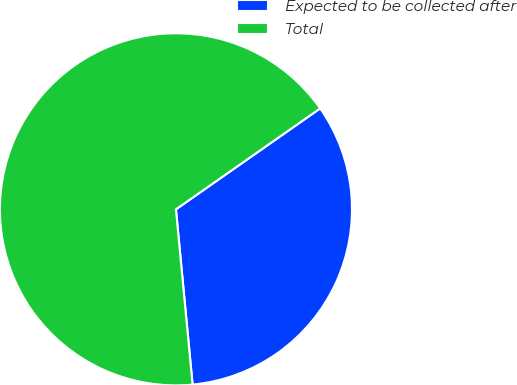Convert chart. <chart><loc_0><loc_0><loc_500><loc_500><pie_chart><fcel>Expected to be collected after<fcel>Total<nl><fcel>33.21%<fcel>66.79%<nl></chart> 